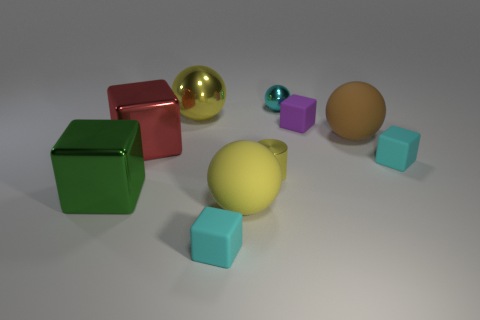Is there anything else that is the same shape as the small yellow thing?
Ensure brevity in your answer.  No. What size is the purple matte thing that is the same shape as the large red object?
Offer a terse response. Small. How many things are rubber blocks that are in front of the large red object or big spheres on the left side of the small cyan ball?
Make the answer very short. 4. There is a tiny cyan thing right of the big brown matte object behind the big yellow matte object; what is its shape?
Offer a terse response. Cube. Is there any other thing that has the same color as the large metal sphere?
Offer a terse response. Yes. What number of things are green blocks or red cubes?
Make the answer very short. 2. Are there any yellow metallic things of the same size as the yellow matte thing?
Keep it short and to the point. Yes. What is the shape of the big red metal thing?
Offer a terse response. Cube. Is the number of big things that are behind the tiny purple thing greater than the number of brown balls to the right of the brown object?
Make the answer very short. Yes. Do the metallic ball left of the tiny cyan ball and the big rubber ball on the left side of the yellow cylinder have the same color?
Provide a succinct answer. Yes. 